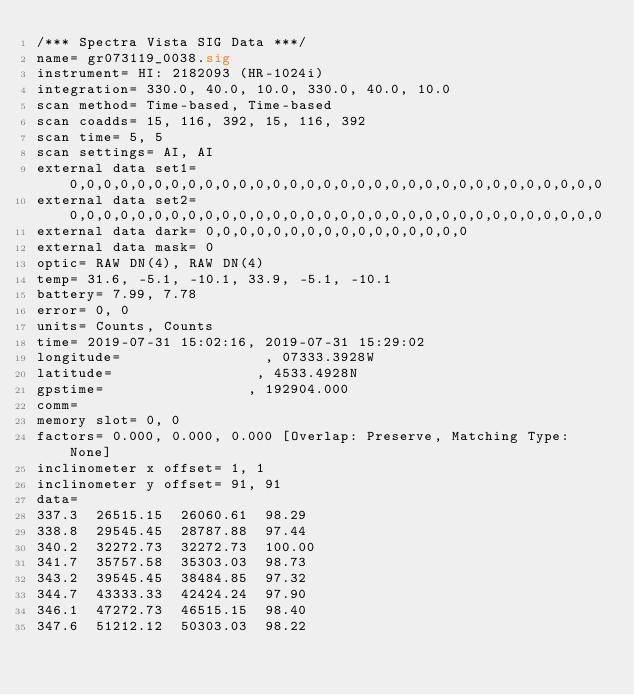Convert code to text. <code><loc_0><loc_0><loc_500><loc_500><_SML_>/*** Spectra Vista SIG Data ***/
name= gr073119_0038.sig
instrument= HI: 2182093 (HR-1024i)
integration= 330.0, 40.0, 10.0, 330.0, 40.0, 10.0
scan method= Time-based, Time-based
scan coadds= 15, 116, 392, 15, 116, 392
scan time= 5, 5
scan settings= AI, AI
external data set1= 0,0,0,0,0,0,0,0,0,0,0,0,0,0,0,0,0,0,0,0,0,0,0,0,0,0,0,0,0,0,0,0
external data set2= 0,0,0,0,0,0,0,0,0,0,0,0,0,0,0,0,0,0,0,0,0,0,0,0,0,0,0,0,0,0,0,0
external data dark= 0,0,0,0,0,0,0,0,0,0,0,0,0,0,0,0
external data mask= 0
optic= RAW DN(4), RAW DN(4)
temp= 31.6, -5.1, -10.1, 33.9, -5.1, -10.1
battery= 7.99, 7.78
error= 0, 0
units= Counts, Counts
time= 2019-07-31 15:02:16, 2019-07-31 15:29:02
longitude=                 , 07333.3928W     
latitude=                 , 4533.4928N      
gpstime=                 , 192904.000      
comm= 
memory slot= 0, 0
factors= 0.000, 0.000, 0.000 [Overlap: Preserve, Matching Type: None]
inclinometer x offset= 1, 1
inclinometer y offset= 91, 91
data= 
337.3  26515.15  26060.61  98.29
338.8  29545.45  28787.88  97.44
340.2  32272.73  32272.73  100.00
341.7  35757.58  35303.03  98.73
343.2  39545.45  38484.85  97.32
344.7  43333.33  42424.24  97.90
346.1  47272.73  46515.15  98.40
347.6  51212.12  50303.03  98.22</code> 